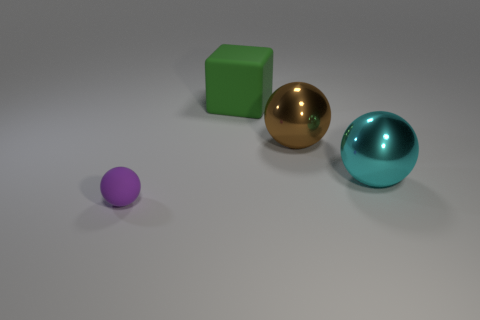Do the thing in front of the cyan shiny object and the brown thing have the same material? no 